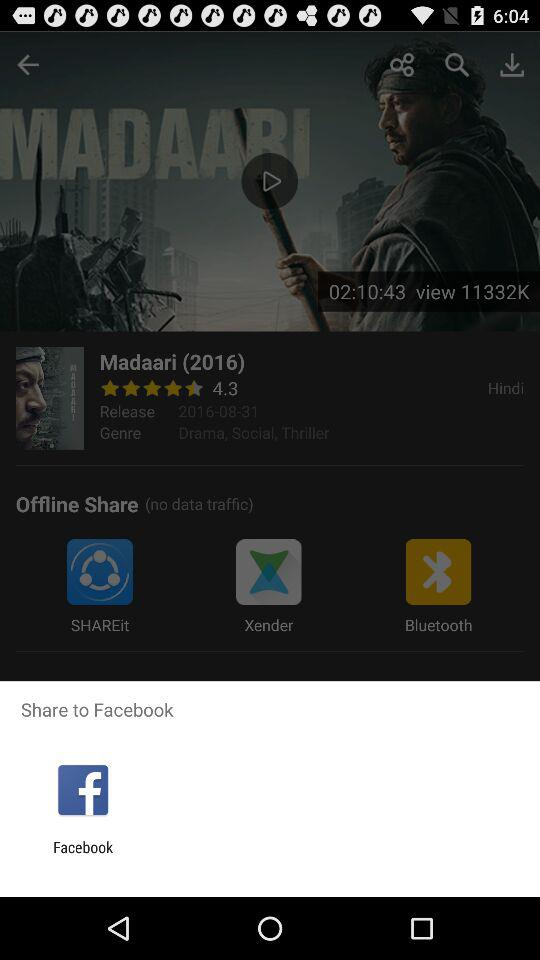How many genre does the movie have?
Answer the question using a single word or phrase. 3 